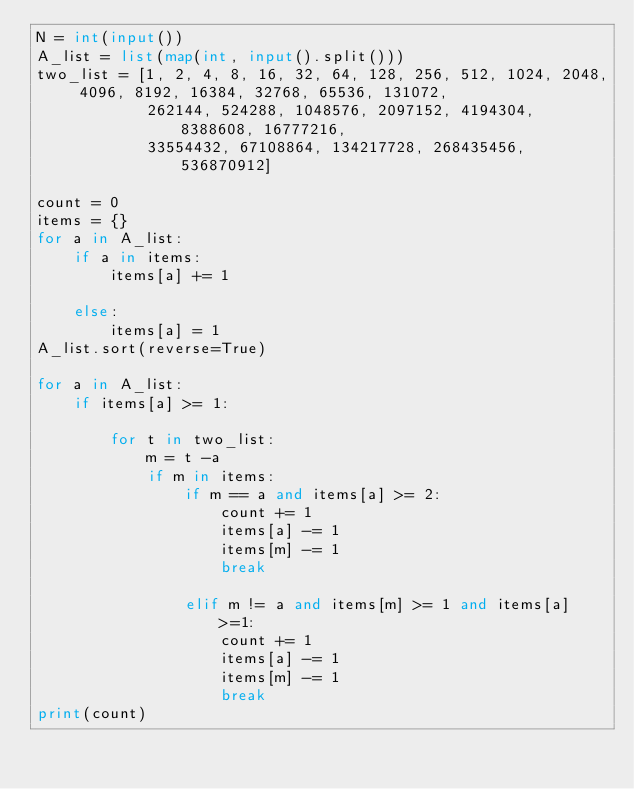<code> <loc_0><loc_0><loc_500><loc_500><_Python_>N = int(input())
A_list = list(map(int, input().split()))
two_list = [1, 2, 4, 8, 16, 32, 64, 128, 256, 512, 1024, 2048, 4096, 8192, 16384, 32768, 65536, 131072,
            262144, 524288, 1048576, 2097152, 4194304, 8388608, 16777216,
            33554432, 67108864, 134217728, 268435456, 536870912]

count = 0
items = {}
for a in A_list:
    if a in items:
        items[a] += 1

    else:
        items[a] = 1
A_list.sort(reverse=True)

for a in A_list:
    if items[a] >= 1:

        for t in two_list:
            m = t -a
            if m in items:
                if m == a and items[a] >= 2:
                    count += 1
                    items[a] -= 1
                    items[m] -= 1
                    break

                elif m != a and items[m] >= 1 and items[a] >=1:
                    count += 1
                    items[a] -= 1
                    items[m] -= 1
                    break
print(count)
</code> 